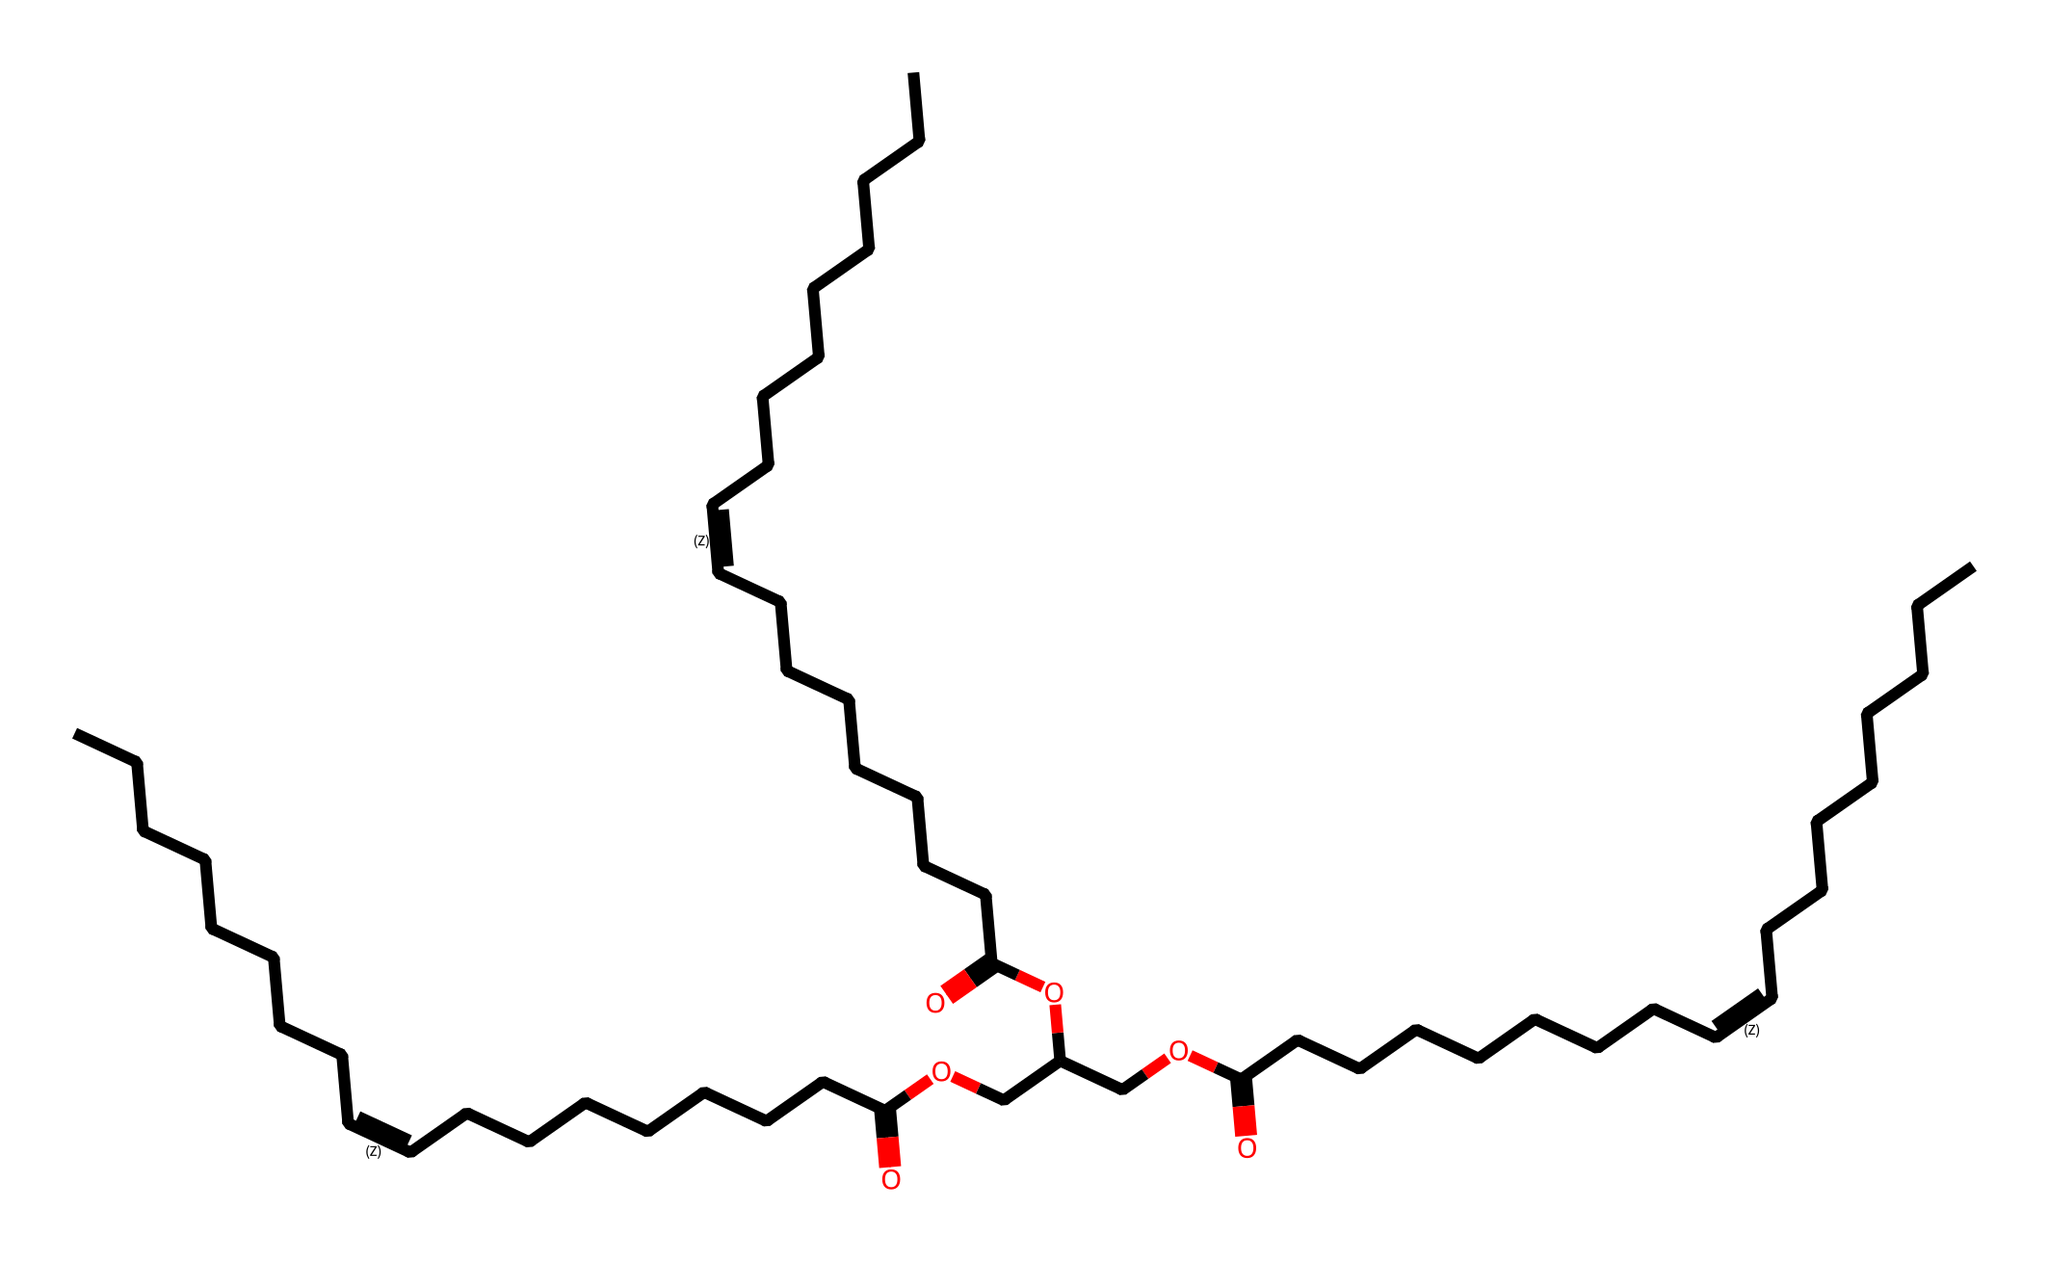what type of compound is represented by this structure? The given SMILES represents a compound with carbon and hydrogen in a chain-like structure, typically classified as an aliphatic compound. The presence of long carbon chains and no rings confirms this classification.
Answer: aliphatic how many carbon atoms are present in the structure? Analyzing the SMILES notation reveals a long chain with multiple segments. Counting each carbon atom in the long chains and branches indicates that there are 30 carbon atoms in total.
Answer: 30 does the structure have double bonds? By examining the SMILES string, the notation "/C=C\" indicates the presence of double bonds in the compound. The formula contains multiple instances of this notation, indicating multiple double bonds.
Answer: yes what functional group is present in the compound? The presence of "O" and "OCC" in the SMILES indicates the existence of ester groups in the compound. The connection of carbon chains and oxygen atoms arranged in this manner signifies the ester functional group.
Answer: ester what is the role of olive oil in Greek cuisine? While not directly part of the chemical structure, olive oil is essential in Greek cuisine for flavoring, cooking, and health benefits, attributed to its composition of fatty acids and antioxidant properties.
Answer: essential how many double bonds are present in this structure? Upon closer examination of the SMILES, each occurrence of "/C=C\" indicates a double bond. By systematically counting these occurrences through the structure, we find there are three double bonds present.
Answer: 3 